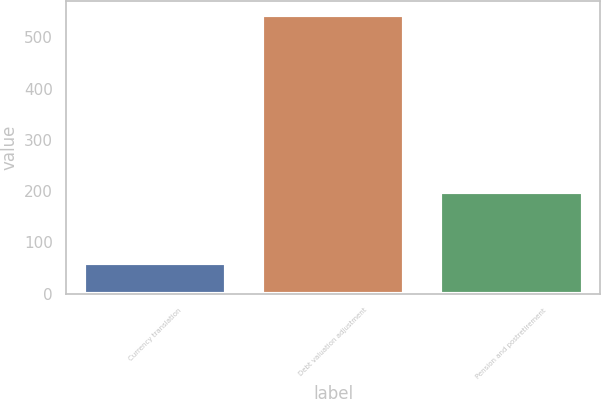Convert chart. <chart><loc_0><loc_0><loc_500><loc_500><bar_chart><fcel>Currency translation<fcel>Debt valuation adjustment<fcel>Pension and postretirement<nl><fcel>60<fcel>544<fcel>199<nl></chart> 